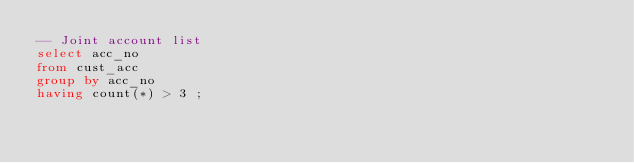Convert code to text. <code><loc_0><loc_0><loc_500><loc_500><_SQL_>-- Joint account list
select acc_no
from cust_acc
group by acc_no
having count(*) > 3 ; </code> 